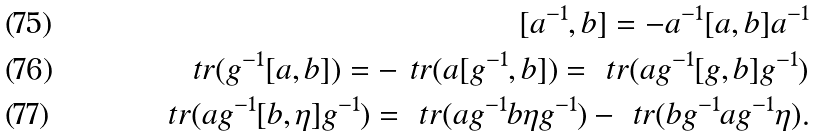Convert formula to latex. <formula><loc_0><loc_0><loc_500><loc_500>[ a ^ { - 1 } , b ] = - a ^ { - 1 } [ a , b ] a ^ { - 1 } \\ \ t r ( g ^ { - 1 } [ a , b ] ) = - \ t r ( a [ g ^ { - 1 } , b ] ) = \ t r ( a g ^ { - 1 } [ g , b ] g ^ { - 1 } ) \\ \ t r ( a g ^ { - 1 } [ b , \eta ] g ^ { - 1 } ) = \ t r ( a g ^ { - 1 } b \eta g ^ { - 1 } ) - \ t r ( b g ^ { - 1 } a g ^ { - 1 } \eta ) .</formula> 